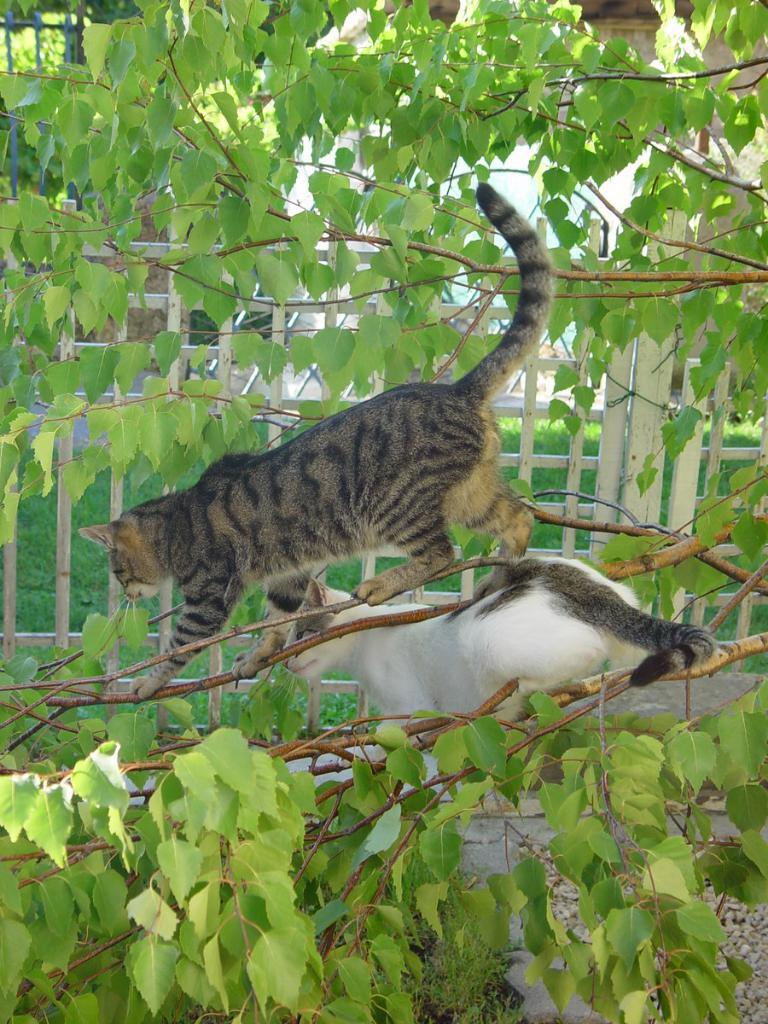What animals are on the tree in the image? There are two cats on the branches of a tree in the image. What can be seen in the background behind the tree? In the background, there is a fence, poles, trees, and an unspecified object. What type of ground is visible in the image? Grass is present on the ground in the image. What type of army is marching through the grass in the image? There is no army present in the image; it features two cats on a tree and various background elements. 